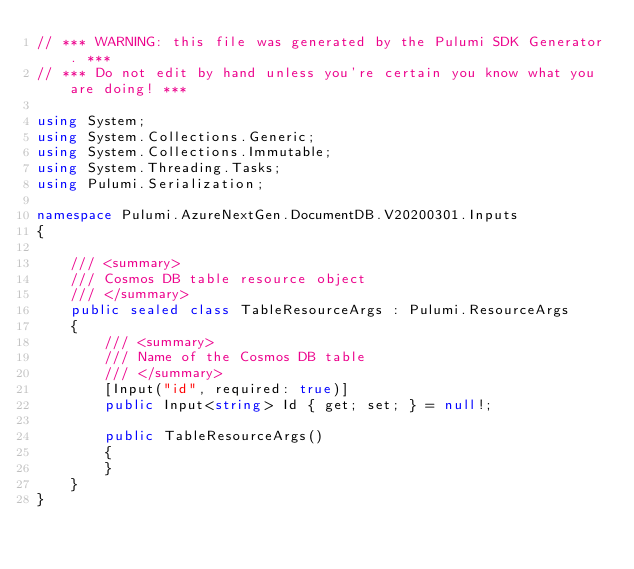Convert code to text. <code><loc_0><loc_0><loc_500><loc_500><_C#_>// *** WARNING: this file was generated by the Pulumi SDK Generator. ***
// *** Do not edit by hand unless you're certain you know what you are doing! ***

using System;
using System.Collections.Generic;
using System.Collections.Immutable;
using System.Threading.Tasks;
using Pulumi.Serialization;

namespace Pulumi.AzureNextGen.DocumentDB.V20200301.Inputs
{

    /// <summary>
    /// Cosmos DB table resource object
    /// </summary>
    public sealed class TableResourceArgs : Pulumi.ResourceArgs
    {
        /// <summary>
        /// Name of the Cosmos DB table
        /// </summary>
        [Input("id", required: true)]
        public Input<string> Id { get; set; } = null!;

        public TableResourceArgs()
        {
        }
    }
}
</code> 